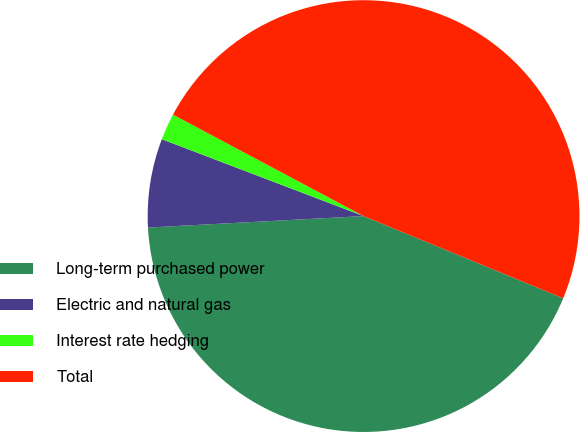Convert chart. <chart><loc_0><loc_0><loc_500><loc_500><pie_chart><fcel>Long-term purchased power<fcel>Electric and natural gas<fcel>Interest rate hedging<fcel>Total<nl><fcel>42.94%<fcel>6.64%<fcel>1.99%<fcel>48.43%<nl></chart> 